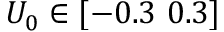<formula> <loc_0><loc_0><loc_500><loc_500>U _ { 0 } \in [ - 0 . 3 0 . 3 ]</formula> 